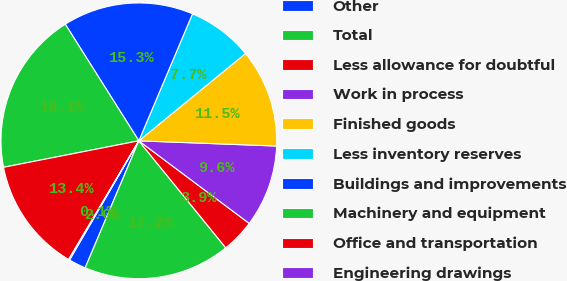<chart> <loc_0><loc_0><loc_500><loc_500><pie_chart><fcel>Other<fcel>Total<fcel>Less allowance for doubtful<fcel>Work in process<fcel>Finished goods<fcel>Less inventory reserves<fcel>Buildings and improvements<fcel>Machinery and equipment<fcel>Office and transportation<fcel>Engineering drawings<nl><fcel>2.02%<fcel>17.22%<fcel>3.92%<fcel>9.62%<fcel>11.52%<fcel>7.72%<fcel>15.32%<fcel>19.12%<fcel>13.42%<fcel>0.12%<nl></chart> 